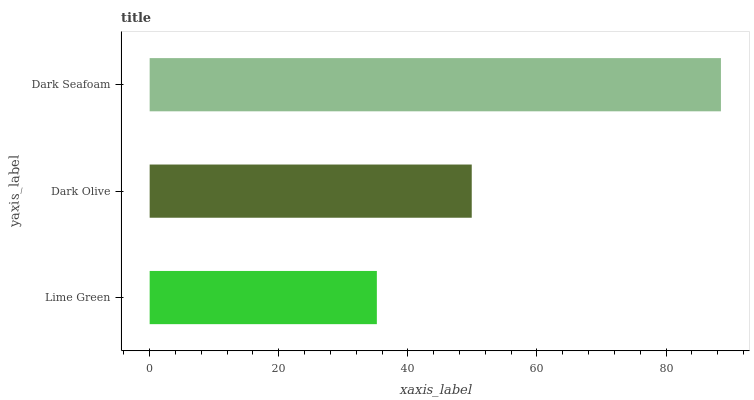Is Lime Green the minimum?
Answer yes or no. Yes. Is Dark Seafoam the maximum?
Answer yes or no. Yes. Is Dark Olive the minimum?
Answer yes or no. No. Is Dark Olive the maximum?
Answer yes or no. No. Is Dark Olive greater than Lime Green?
Answer yes or no. Yes. Is Lime Green less than Dark Olive?
Answer yes or no. Yes. Is Lime Green greater than Dark Olive?
Answer yes or no. No. Is Dark Olive less than Lime Green?
Answer yes or no. No. Is Dark Olive the high median?
Answer yes or no. Yes. Is Dark Olive the low median?
Answer yes or no. Yes. Is Lime Green the high median?
Answer yes or no. No. Is Lime Green the low median?
Answer yes or no. No. 